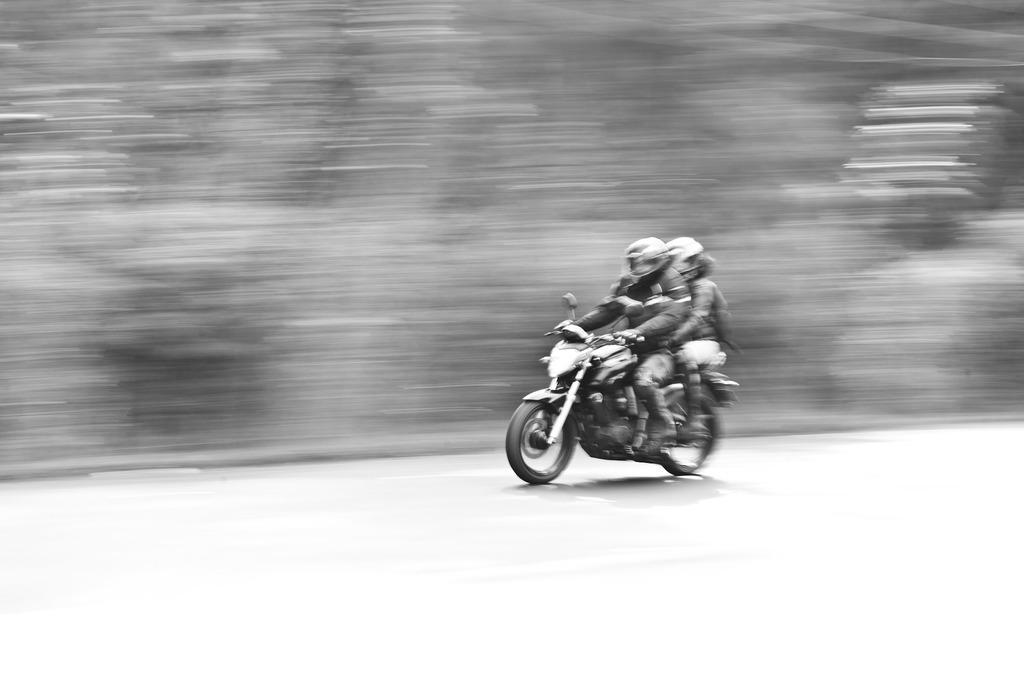In one or two sentences, can you explain what this image depicts? In this image two persons are riding a bike wearing helmets. 